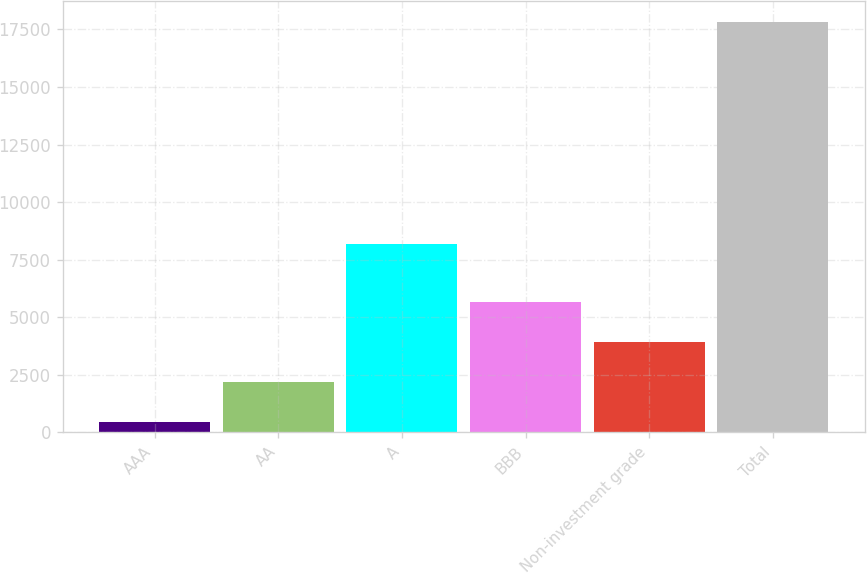Convert chart to OTSL. <chart><loc_0><loc_0><loc_500><loc_500><bar_chart><fcel>AAA<fcel>AA<fcel>A<fcel>BBB<fcel>Non-investment grade<fcel>Total<nl><fcel>453<fcel>2191.7<fcel>8191<fcel>5669.1<fcel>3930.4<fcel>17840<nl></chart> 